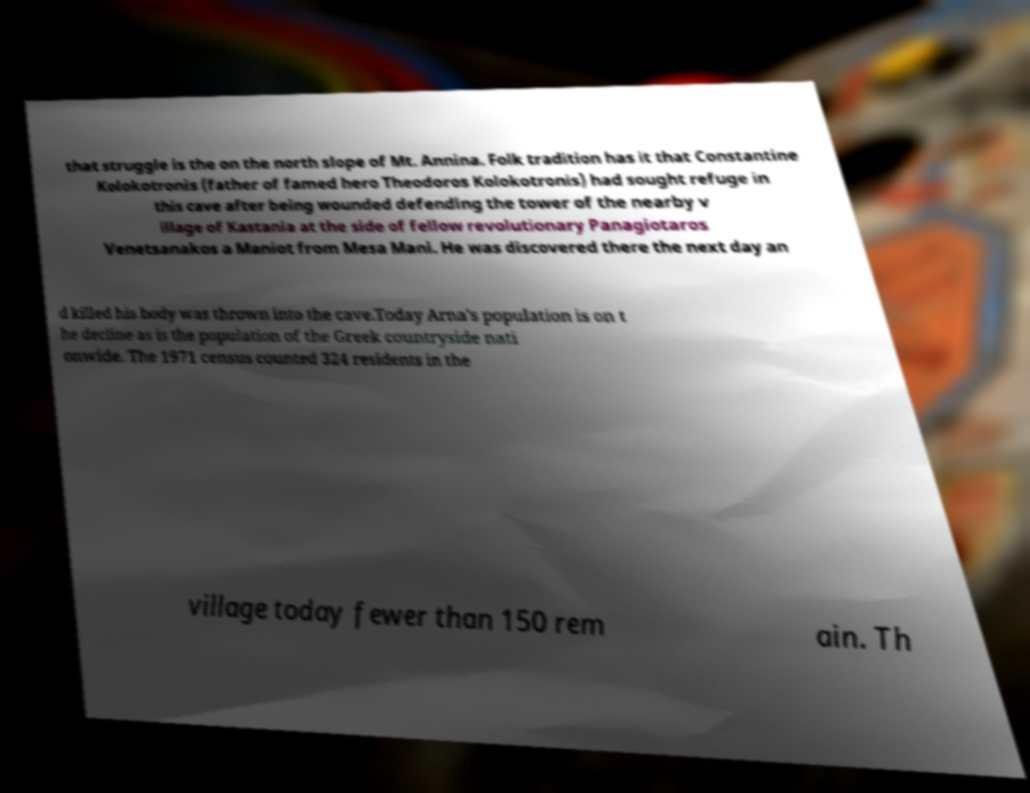For documentation purposes, I need the text within this image transcribed. Could you provide that? that struggle is the on the north slope of Mt. Annina. Folk tradition has it that Constantine Kolokotronis (father of famed hero Theodoros Kolokotronis) had sought refuge in this cave after being wounded defending the tower of the nearby v illage of Kastania at the side of fellow revolutionary Panagiotaros Venetsanakos a Maniot from Mesa Mani. He was discovered there the next day an d killed his body was thrown into the cave.Today Arna's population is on t he decline as is the population of the Greek countryside nati onwide. The 1971 census counted 324 residents in the village today fewer than 150 rem ain. Th 